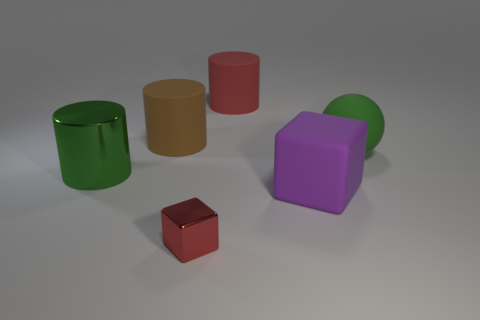Add 4 tiny red cylinders. How many objects exist? 10 Subtract all spheres. How many objects are left? 5 Subtract all large matte cylinders. How many cylinders are left? 1 Subtract 1 red blocks. How many objects are left? 5 Subtract 2 blocks. How many blocks are left? 0 Subtract all green cylinders. Subtract all gray blocks. How many cylinders are left? 2 Subtract all red cubes. How many red cylinders are left? 1 Subtract all yellow metallic cubes. Subtract all green rubber things. How many objects are left? 5 Add 3 big green cylinders. How many big green cylinders are left? 4 Add 6 metallic cylinders. How many metallic cylinders exist? 7 